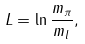Convert formula to latex. <formula><loc_0><loc_0><loc_500><loc_500>L = \ln { \frac { m _ { \pi } } { m _ { l } } } ,</formula> 